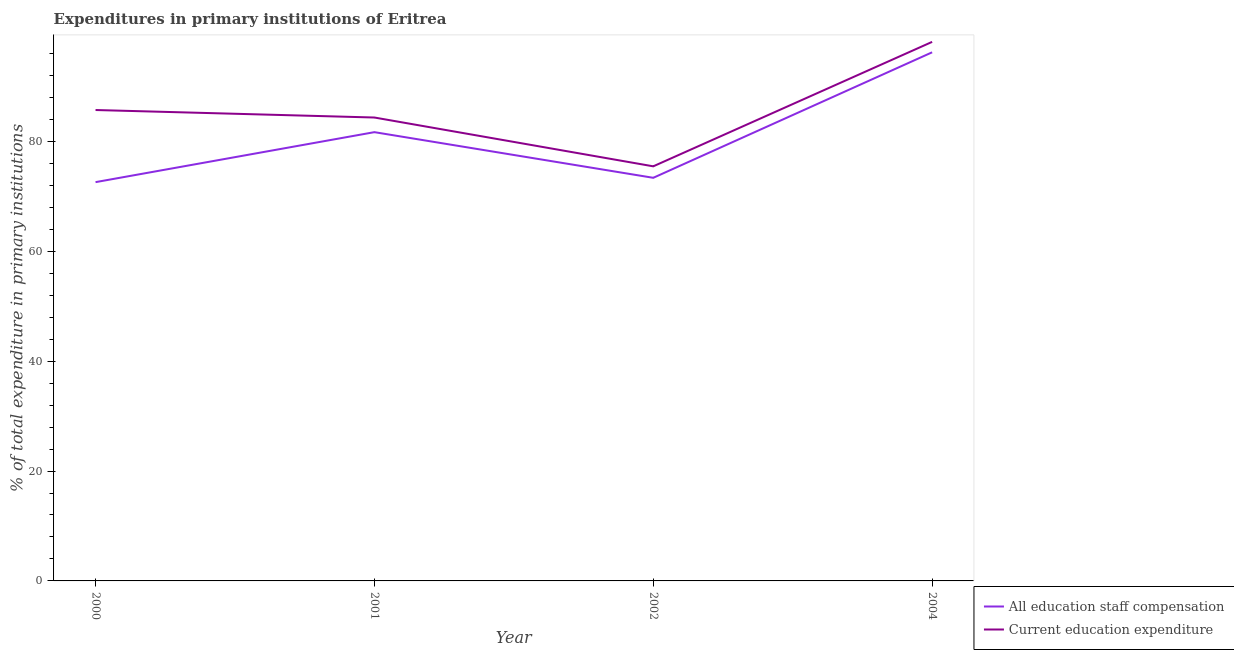How many different coloured lines are there?
Provide a short and direct response. 2. What is the expenditure in education in 2000?
Your response must be concise. 85.7. Across all years, what is the maximum expenditure in education?
Ensure brevity in your answer.  98.1. Across all years, what is the minimum expenditure in education?
Offer a terse response. 75.45. In which year was the expenditure in staff compensation minimum?
Make the answer very short. 2000. What is the total expenditure in staff compensation in the graph?
Keep it short and to the point. 323.81. What is the difference between the expenditure in education in 2000 and that in 2002?
Give a very brief answer. 10.25. What is the difference between the expenditure in staff compensation in 2002 and the expenditure in education in 2001?
Your answer should be compact. -10.97. What is the average expenditure in education per year?
Give a very brief answer. 85.9. In the year 2000, what is the difference between the expenditure in staff compensation and expenditure in education?
Keep it short and to the point. -13.13. What is the ratio of the expenditure in education in 2000 to that in 2001?
Your answer should be compact. 1.02. Is the expenditure in staff compensation in 2000 less than that in 2004?
Offer a very short reply. Yes. What is the difference between the highest and the second highest expenditure in education?
Ensure brevity in your answer.  12.4. What is the difference between the highest and the lowest expenditure in staff compensation?
Keep it short and to the point. 23.63. Does the expenditure in staff compensation monotonically increase over the years?
Ensure brevity in your answer.  No. Is the expenditure in education strictly greater than the expenditure in staff compensation over the years?
Your answer should be compact. Yes. How many years are there in the graph?
Provide a short and direct response. 4. Are the values on the major ticks of Y-axis written in scientific E-notation?
Provide a succinct answer. No. Does the graph contain grids?
Make the answer very short. No. Where does the legend appear in the graph?
Your response must be concise. Bottom right. How many legend labels are there?
Provide a succinct answer. 2. What is the title of the graph?
Provide a short and direct response. Expenditures in primary institutions of Eritrea. Does "Grants" appear as one of the legend labels in the graph?
Your answer should be very brief. No. What is the label or title of the Y-axis?
Provide a succinct answer. % of total expenditure in primary institutions. What is the % of total expenditure in primary institutions in All education staff compensation in 2000?
Give a very brief answer. 72.57. What is the % of total expenditure in primary institutions in Current education expenditure in 2000?
Your answer should be very brief. 85.7. What is the % of total expenditure in primary institutions of All education staff compensation in 2001?
Provide a short and direct response. 81.67. What is the % of total expenditure in primary institutions of Current education expenditure in 2001?
Make the answer very short. 84.33. What is the % of total expenditure in primary institutions in All education staff compensation in 2002?
Keep it short and to the point. 73.36. What is the % of total expenditure in primary institutions in Current education expenditure in 2002?
Offer a terse response. 75.45. What is the % of total expenditure in primary institutions of All education staff compensation in 2004?
Keep it short and to the point. 96.2. What is the % of total expenditure in primary institutions in Current education expenditure in 2004?
Your answer should be compact. 98.1. Across all years, what is the maximum % of total expenditure in primary institutions of All education staff compensation?
Provide a short and direct response. 96.2. Across all years, what is the maximum % of total expenditure in primary institutions of Current education expenditure?
Offer a very short reply. 98.1. Across all years, what is the minimum % of total expenditure in primary institutions of All education staff compensation?
Your answer should be very brief. 72.57. Across all years, what is the minimum % of total expenditure in primary institutions in Current education expenditure?
Your answer should be very brief. 75.45. What is the total % of total expenditure in primary institutions of All education staff compensation in the graph?
Provide a short and direct response. 323.81. What is the total % of total expenditure in primary institutions in Current education expenditure in the graph?
Offer a very short reply. 343.59. What is the difference between the % of total expenditure in primary institutions of All education staff compensation in 2000 and that in 2001?
Make the answer very short. -9.1. What is the difference between the % of total expenditure in primary institutions of Current education expenditure in 2000 and that in 2001?
Your answer should be very brief. 1.37. What is the difference between the % of total expenditure in primary institutions in All education staff compensation in 2000 and that in 2002?
Offer a terse response. -0.79. What is the difference between the % of total expenditure in primary institutions in Current education expenditure in 2000 and that in 2002?
Provide a succinct answer. 10.25. What is the difference between the % of total expenditure in primary institutions of All education staff compensation in 2000 and that in 2004?
Keep it short and to the point. -23.63. What is the difference between the % of total expenditure in primary institutions of Current education expenditure in 2000 and that in 2004?
Provide a succinct answer. -12.4. What is the difference between the % of total expenditure in primary institutions in All education staff compensation in 2001 and that in 2002?
Offer a very short reply. 8.31. What is the difference between the % of total expenditure in primary institutions of Current education expenditure in 2001 and that in 2002?
Ensure brevity in your answer.  8.88. What is the difference between the % of total expenditure in primary institutions in All education staff compensation in 2001 and that in 2004?
Provide a short and direct response. -14.53. What is the difference between the % of total expenditure in primary institutions of Current education expenditure in 2001 and that in 2004?
Provide a short and direct response. -13.76. What is the difference between the % of total expenditure in primary institutions in All education staff compensation in 2002 and that in 2004?
Your answer should be very brief. -22.84. What is the difference between the % of total expenditure in primary institutions in Current education expenditure in 2002 and that in 2004?
Offer a very short reply. -22.65. What is the difference between the % of total expenditure in primary institutions in All education staff compensation in 2000 and the % of total expenditure in primary institutions in Current education expenditure in 2001?
Offer a terse response. -11.76. What is the difference between the % of total expenditure in primary institutions in All education staff compensation in 2000 and the % of total expenditure in primary institutions in Current education expenditure in 2002?
Provide a succinct answer. -2.88. What is the difference between the % of total expenditure in primary institutions of All education staff compensation in 2000 and the % of total expenditure in primary institutions of Current education expenditure in 2004?
Offer a terse response. -25.53. What is the difference between the % of total expenditure in primary institutions in All education staff compensation in 2001 and the % of total expenditure in primary institutions in Current education expenditure in 2002?
Your answer should be very brief. 6.22. What is the difference between the % of total expenditure in primary institutions of All education staff compensation in 2001 and the % of total expenditure in primary institutions of Current education expenditure in 2004?
Your response must be concise. -16.43. What is the difference between the % of total expenditure in primary institutions of All education staff compensation in 2002 and the % of total expenditure in primary institutions of Current education expenditure in 2004?
Offer a very short reply. -24.74. What is the average % of total expenditure in primary institutions of All education staff compensation per year?
Offer a terse response. 80.95. What is the average % of total expenditure in primary institutions of Current education expenditure per year?
Your answer should be compact. 85.9. In the year 2000, what is the difference between the % of total expenditure in primary institutions in All education staff compensation and % of total expenditure in primary institutions in Current education expenditure?
Your response must be concise. -13.13. In the year 2001, what is the difference between the % of total expenditure in primary institutions in All education staff compensation and % of total expenditure in primary institutions in Current education expenditure?
Give a very brief answer. -2.66. In the year 2002, what is the difference between the % of total expenditure in primary institutions in All education staff compensation and % of total expenditure in primary institutions in Current education expenditure?
Offer a very short reply. -2.09. In the year 2004, what is the difference between the % of total expenditure in primary institutions of All education staff compensation and % of total expenditure in primary institutions of Current education expenditure?
Give a very brief answer. -1.9. What is the ratio of the % of total expenditure in primary institutions of All education staff compensation in 2000 to that in 2001?
Give a very brief answer. 0.89. What is the ratio of the % of total expenditure in primary institutions in Current education expenditure in 2000 to that in 2001?
Offer a terse response. 1.02. What is the ratio of the % of total expenditure in primary institutions in Current education expenditure in 2000 to that in 2002?
Give a very brief answer. 1.14. What is the ratio of the % of total expenditure in primary institutions in All education staff compensation in 2000 to that in 2004?
Make the answer very short. 0.75. What is the ratio of the % of total expenditure in primary institutions in Current education expenditure in 2000 to that in 2004?
Make the answer very short. 0.87. What is the ratio of the % of total expenditure in primary institutions in All education staff compensation in 2001 to that in 2002?
Your response must be concise. 1.11. What is the ratio of the % of total expenditure in primary institutions of Current education expenditure in 2001 to that in 2002?
Your response must be concise. 1.12. What is the ratio of the % of total expenditure in primary institutions in All education staff compensation in 2001 to that in 2004?
Offer a terse response. 0.85. What is the ratio of the % of total expenditure in primary institutions of Current education expenditure in 2001 to that in 2004?
Provide a short and direct response. 0.86. What is the ratio of the % of total expenditure in primary institutions of All education staff compensation in 2002 to that in 2004?
Your response must be concise. 0.76. What is the ratio of the % of total expenditure in primary institutions in Current education expenditure in 2002 to that in 2004?
Offer a very short reply. 0.77. What is the difference between the highest and the second highest % of total expenditure in primary institutions of All education staff compensation?
Offer a very short reply. 14.53. What is the difference between the highest and the second highest % of total expenditure in primary institutions in Current education expenditure?
Make the answer very short. 12.4. What is the difference between the highest and the lowest % of total expenditure in primary institutions of All education staff compensation?
Make the answer very short. 23.63. What is the difference between the highest and the lowest % of total expenditure in primary institutions of Current education expenditure?
Make the answer very short. 22.65. 